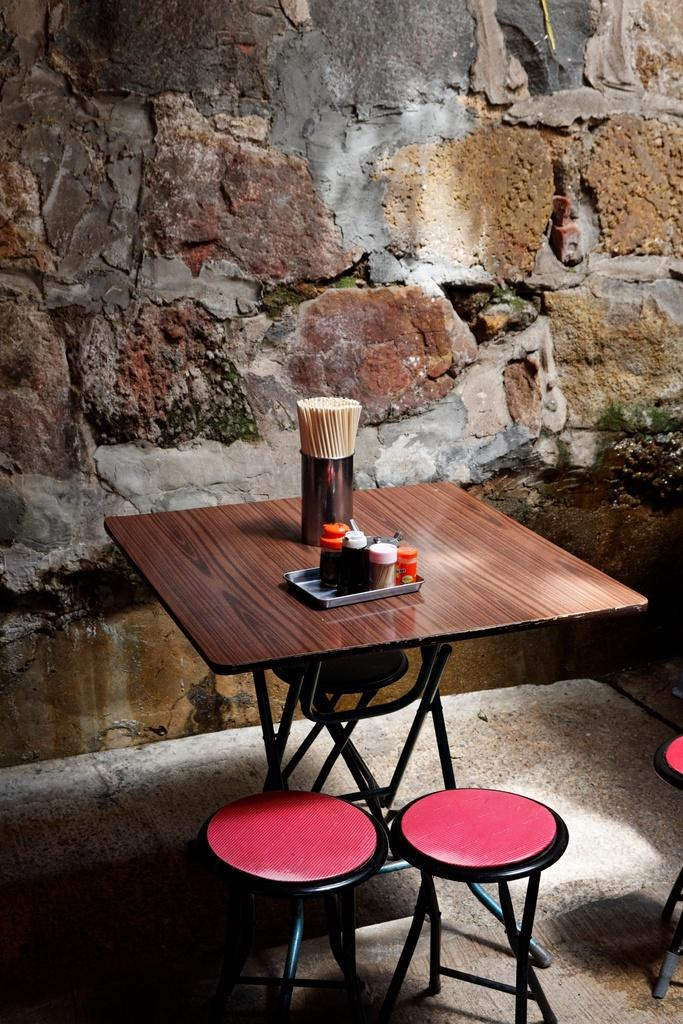What is the main piece of furniture in the image? There is a table with objects in the image. What type of seating is present in the image? There are stools in the image. What can be seen below the table and stools in the image? The ground is visible in the image. What is the background of the image composed of? There is a wall in the image. What type of sign is hanging on the wall in the image? There is no sign present on the wall in the image. What shape is the bed in the image? There is no bed present in the image. 